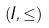Convert formula to latex. <formula><loc_0><loc_0><loc_500><loc_500>( I , \leq )</formula> 